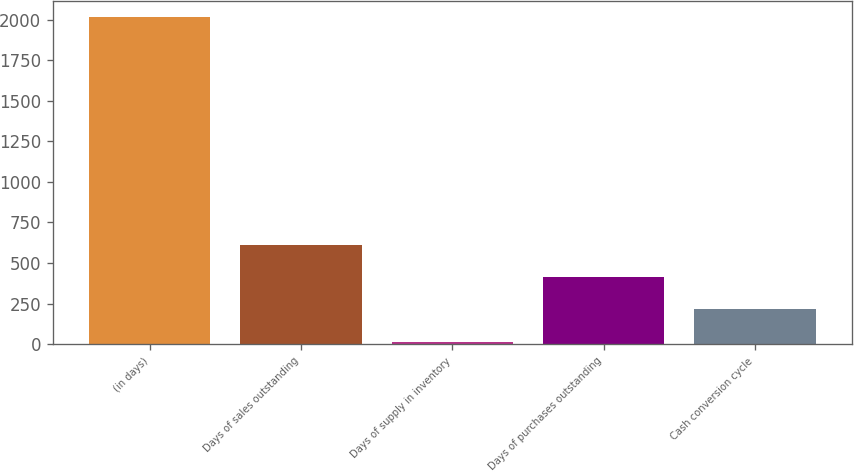Convert chart. <chart><loc_0><loc_0><loc_500><loc_500><bar_chart><fcel>(in days)<fcel>Days of sales outstanding<fcel>Days of supply in inventory<fcel>Days of purchases outstanding<fcel>Cash conversion cycle<nl><fcel>2013<fcel>613.7<fcel>14<fcel>413.8<fcel>213.9<nl></chart> 